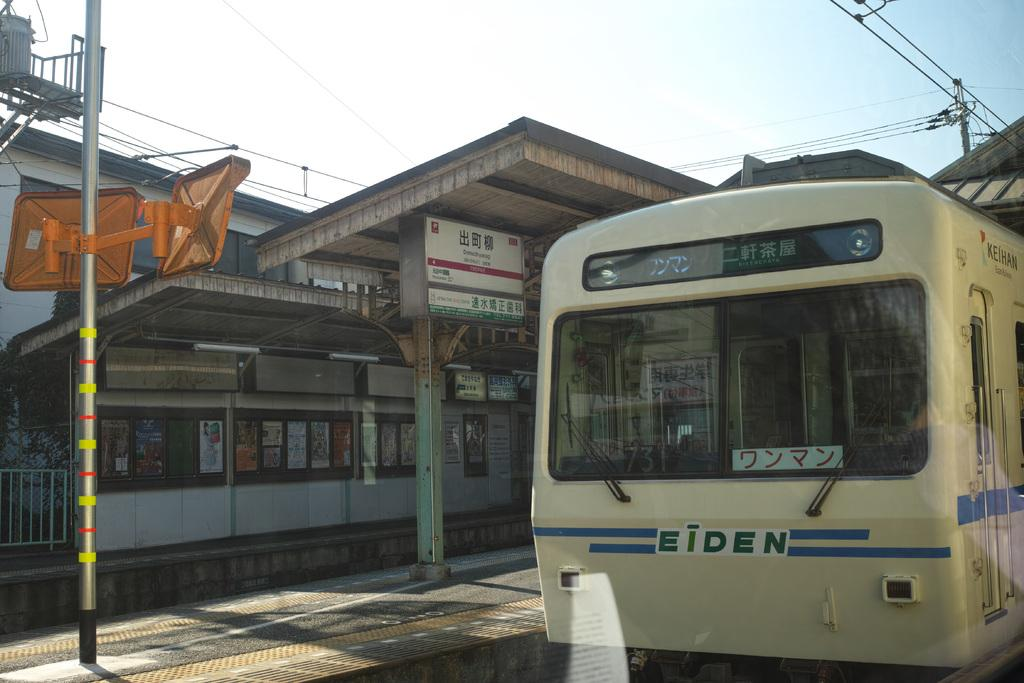What is the main subject of the image? The main subject of the image is a train. What can be seen in the background of the image? There are poles, wires, posters on the wall, and boards with text visible in the background. What part of the train's surroundings can be seen from above? The rooftop is visible in the image. What is visible in the sky in the image? The sky is visible in the image. What grade does the train receive for its performance in the image? The image does not provide any information about the train's performance or a grading system, so it is not possible to answer this question. How many frogs can be seen on the train in the image? There are no frogs present on the train or in the image. 